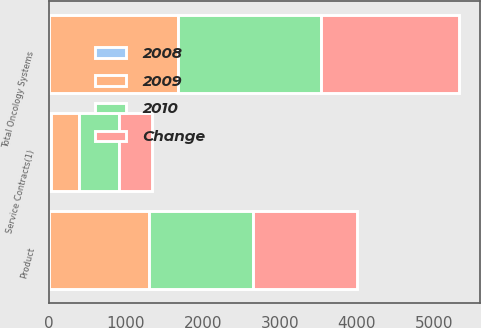Convert chart to OTSL. <chart><loc_0><loc_0><loc_500><loc_500><stacked_bar_chart><ecel><fcel>Product<fcel>Service Contracts(1)<fcel>Total Oncology Systems<nl><fcel>2010<fcel>1343<fcel>519<fcel>1862<nl><fcel>2008<fcel>1<fcel>19<fcel>4<nl><fcel>Change<fcel>1363<fcel>435<fcel>1798<nl><fcel>2009<fcel>1302<fcel>370<fcel>1672<nl></chart> 